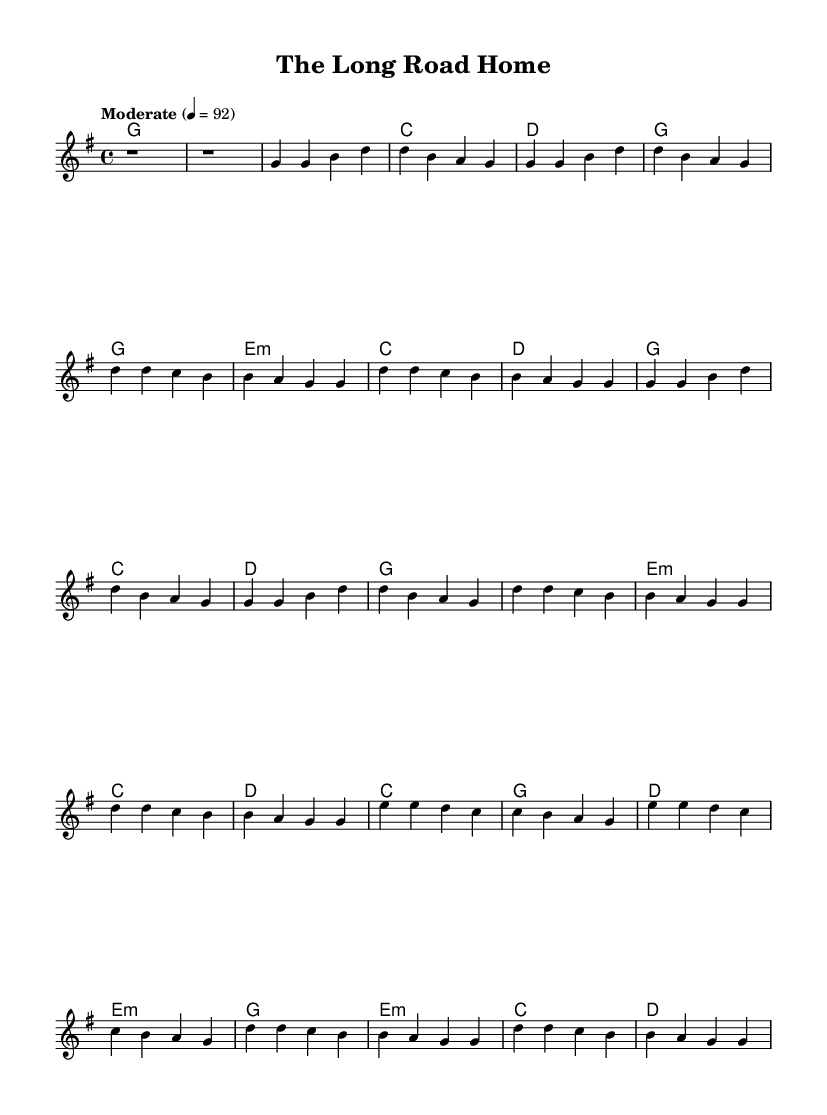What is the key signature of this music? The key signature indicates G major, which has one sharp. The key signature is identified by the sharp symbol placed on the F line in the staff.
Answer: G major What is the time signature of this music? The time signature is indicated at the beginning of the sheet music as 4/4. This means there are four beats in a measure and a quarter note gets one beat.
Answer: 4/4 What is the tempo marking for the piece? The tempo marking appears after the initial setup and indicates "Moderate" at 92 beats per minute. This indicates the speed at which the piece should be performed.
Answer: Moderate 92 How many verses are there in the song structure? By analyzing the layout of the structure in the sheet music, it can be identified that there are two distinct verses marked in the progression of the music.
Answer: 2 What is the chord that accompanies the bridge? Looking at the chord section, the chord accompanying the bridge is specified as C major. This conclusion is drawn from the chord changes listed for that segment of the music.
Answer: C Which chord is played during the chorus? Upon examining the repeated sections of music for the chorus, the chords noted include G major, E minor, C major, and D major collectively in this repetitive structure.
Answer: G, E minor, C, D Which part of the song has a different harmony pattern compared to the verses? The bridge section shows a variation in chord progression and harmony patterns when compared to the verses, denoted by different chords such as C major and E minor, deviating from the simpler pattern found in the verses.
Answer: Bridge 